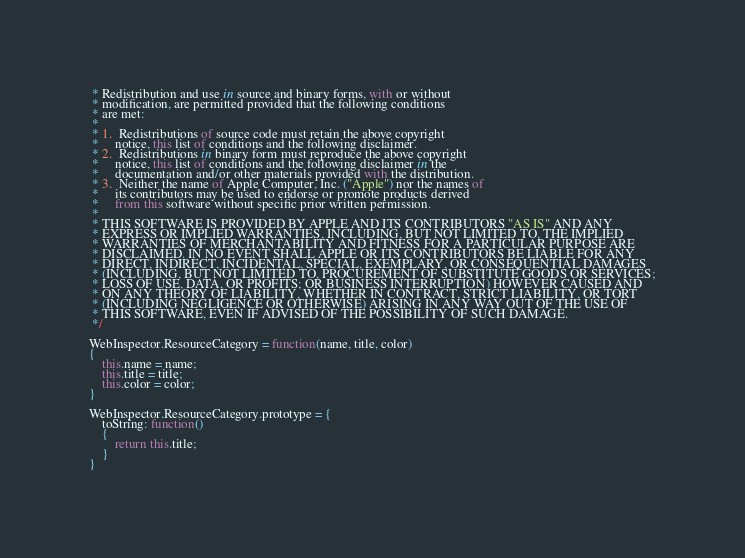<code> <loc_0><loc_0><loc_500><loc_500><_JavaScript_> * Redistribution and use in source and binary forms, with or without
 * modification, are permitted provided that the following conditions
 * are met:
 *
 * 1.  Redistributions of source code must retain the above copyright
 *     notice, this list of conditions and the following disclaimer. 
 * 2.  Redistributions in binary form must reproduce the above copyright
 *     notice, this list of conditions and the following disclaimer in the
 *     documentation and/or other materials provided with the distribution. 
 * 3.  Neither the name of Apple Computer, Inc. ("Apple") nor the names of
 *     its contributors may be used to endorse or promote products derived
 *     from this software without specific prior written permission. 
 *
 * THIS SOFTWARE IS PROVIDED BY APPLE AND ITS CONTRIBUTORS "AS IS" AND ANY
 * EXPRESS OR IMPLIED WARRANTIES, INCLUDING, BUT NOT LIMITED TO, THE IMPLIED
 * WARRANTIES OF MERCHANTABILITY AND FITNESS FOR A PARTICULAR PURPOSE ARE
 * DISCLAIMED. IN NO EVENT SHALL APPLE OR ITS CONTRIBUTORS BE LIABLE FOR ANY
 * DIRECT, INDIRECT, INCIDENTAL, SPECIAL, EXEMPLARY, OR CONSEQUENTIAL DAMAGES
 * (INCLUDING, BUT NOT LIMITED TO, PROCUREMENT OF SUBSTITUTE GOODS OR SERVICES;
 * LOSS OF USE, DATA, OR PROFITS; OR BUSINESS INTERRUPTION) HOWEVER CAUSED AND
 * ON ANY THEORY OF LIABILITY, WHETHER IN CONTRACT, STRICT LIABILITY, OR TORT
 * (INCLUDING NEGLIGENCE OR OTHERWISE) ARISING IN ANY WAY OUT OF THE USE OF
 * THIS SOFTWARE, EVEN IF ADVISED OF THE POSSIBILITY OF SUCH DAMAGE.
 */

WebInspector.ResourceCategory = function(name, title, color)
{
    this.name = name;
    this.title = title;
    this.color = color;
}

WebInspector.ResourceCategory.prototype = {
    toString: function()
    {
        return this.title;
    }
}
</code> 